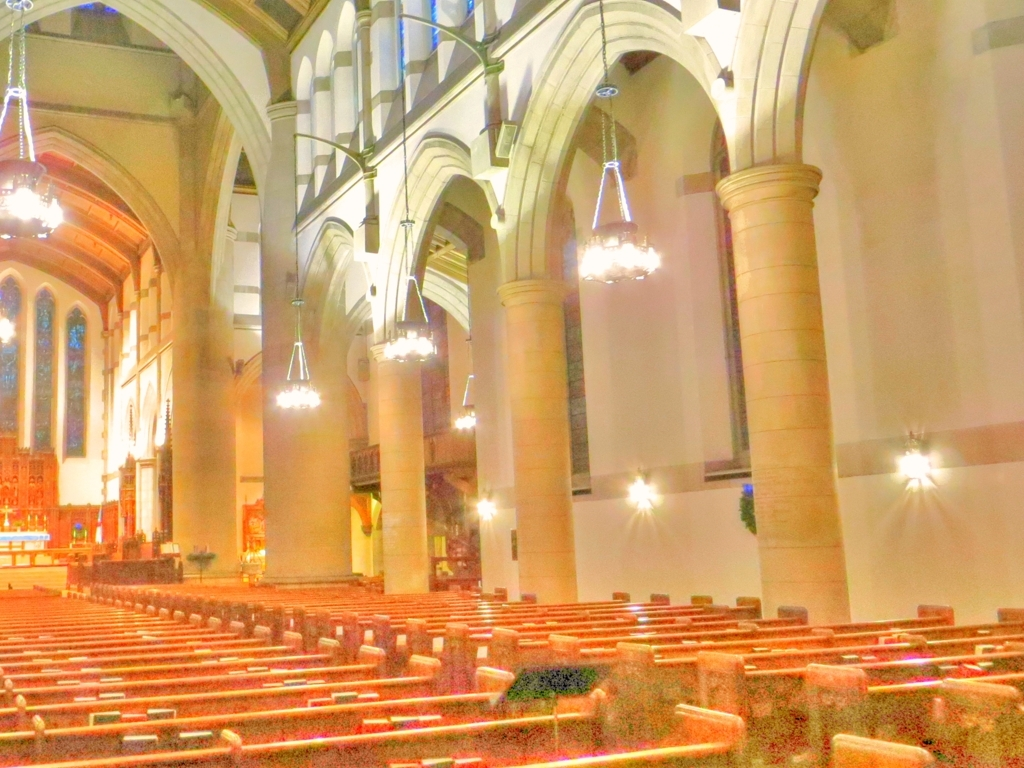Can you describe the architectural style of this building? The interior architecture suggests a Gothic revival style, characterized by the pointed arches above the windows and the tall, narrow columns. The vaulted ceiling and the linear arrangement of the pews also contribute to the Gothic aesthetic. 